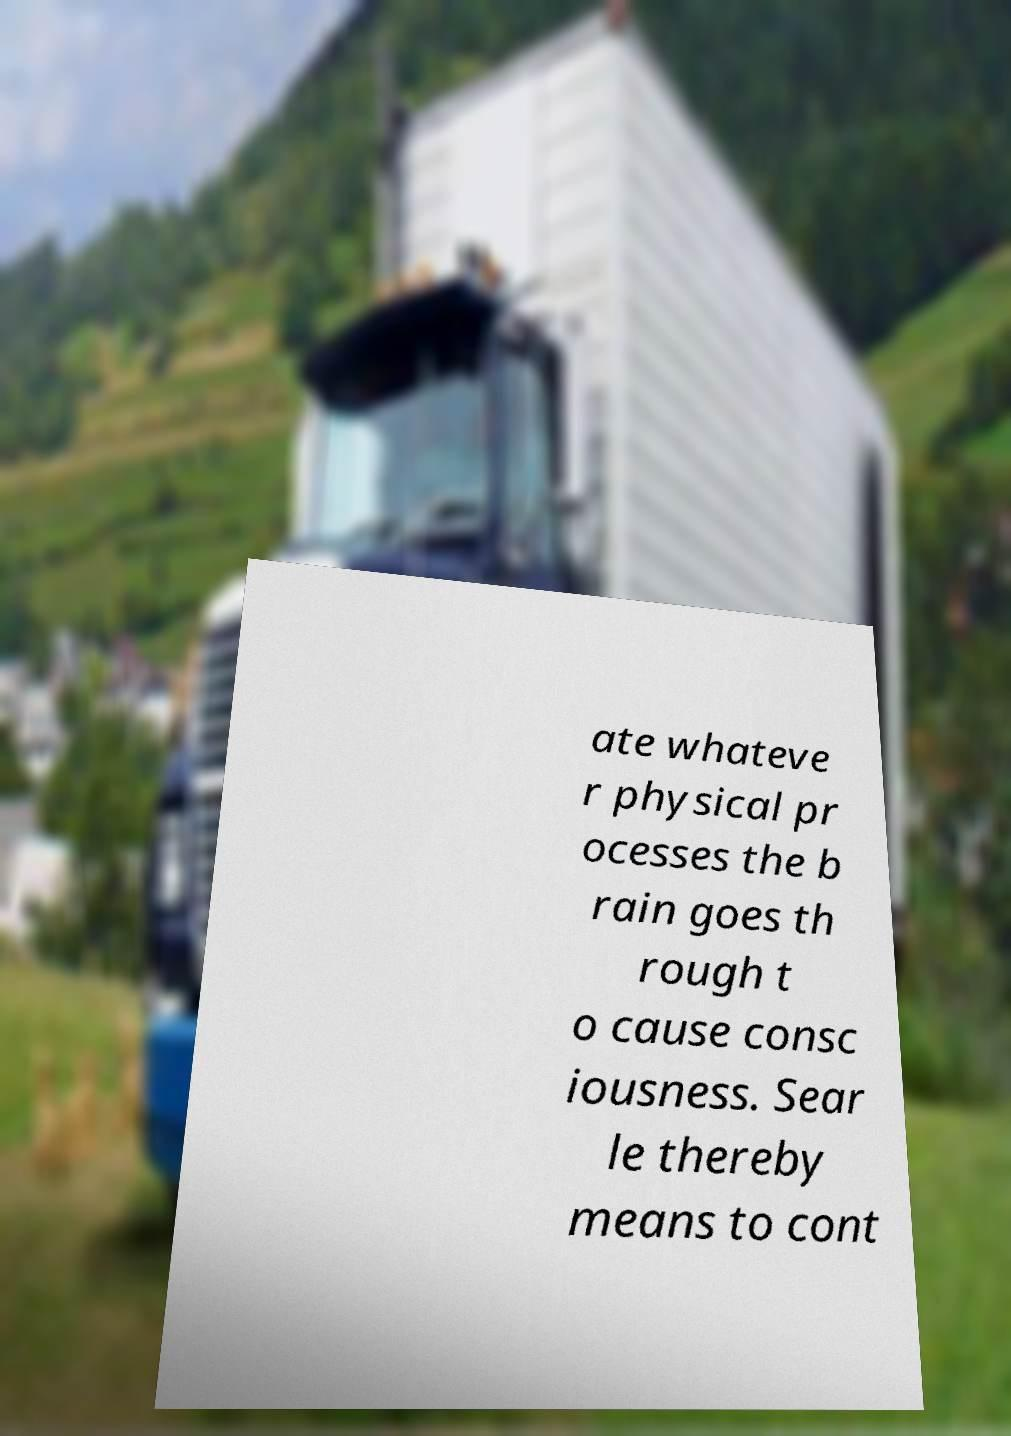Please read and relay the text visible in this image. What does it say? ate whateve r physical pr ocesses the b rain goes th rough t o cause consc iousness. Sear le thereby means to cont 